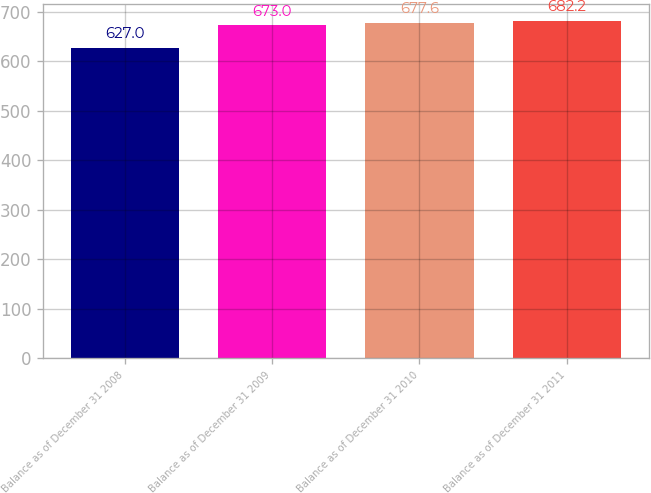Convert chart. <chart><loc_0><loc_0><loc_500><loc_500><bar_chart><fcel>Balance as of December 31 2008<fcel>Balance as of December 31 2009<fcel>Balance as of December 31 2010<fcel>Balance as of December 31 2011<nl><fcel>627<fcel>673<fcel>677.6<fcel>682.2<nl></chart> 